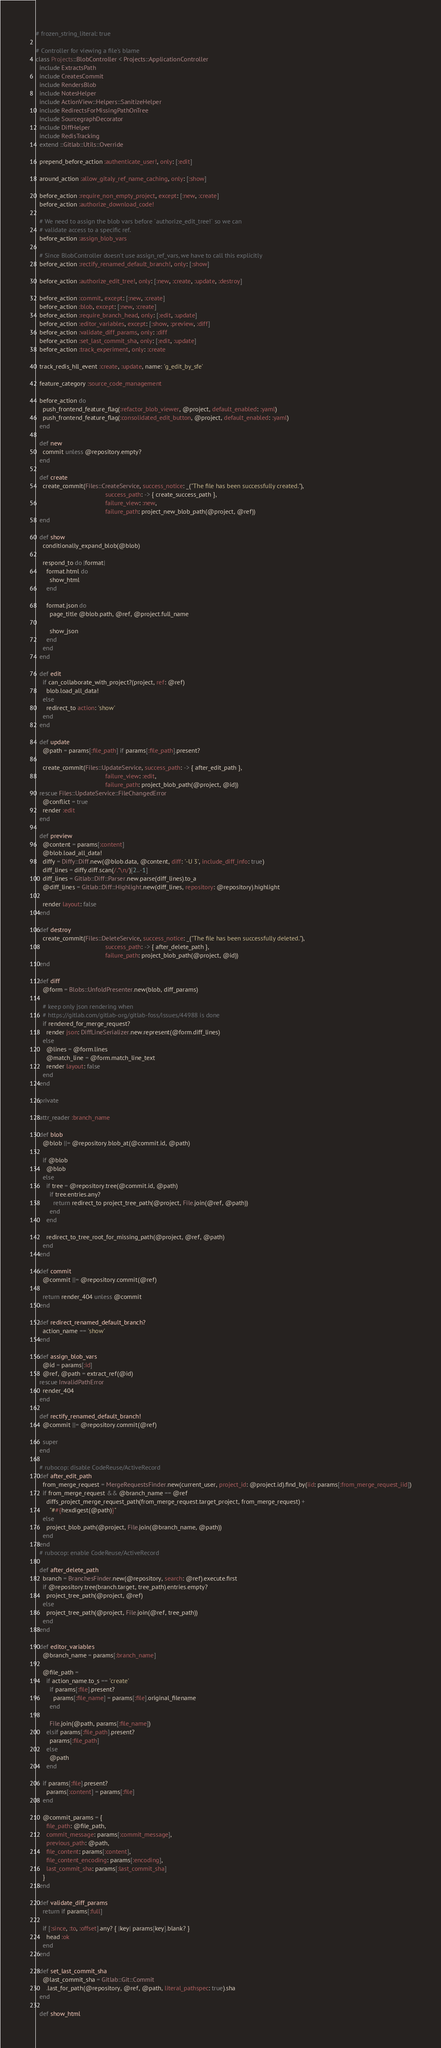<code> <loc_0><loc_0><loc_500><loc_500><_Ruby_># frozen_string_literal: true

# Controller for viewing a file's blame
class Projects::BlobController < Projects::ApplicationController
  include ExtractsPath
  include CreatesCommit
  include RendersBlob
  include NotesHelper
  include ActionView::Helpers::SanitizeHelper
  include RedirectsForMissingPathOnTree
  include SourcegraphDecorator
  include DiffHelper
  include RedisTracking
  extend ::Gitlab::Utils::Override

  prepend_before_action :authenticate_user!, only: [:edit]

  around_action :allow_gitaly_ref_name_caching, only: [:show]

  before_action :require_non_empty_project, except: [:new, :create]
  before_action :authorize_download_code!

  # We need to assign the blob vars before `authorize_edit_tree!` so we can
  # validate access to a specific ref.
  before_action :assign_blob_vars

  # Since BlobController doesn't use assign_ref_vars, we have to call this explicitly
  before_action :rectify_renamed_default_branch!, only: [:show]

  before_action :authorize_edit_tree!, only: [:new, :create, :update, :destroy]

  before_action :commit, except: [:new, :create]
  before_action :blob, except: [:new, :create]
  before_action :require_branch_head, only: [:edit, :update]
  before_action :editor_variables, except: [:show, :preview, :diff]
  before_action :validate_diff_params, only: :diff
  before_action :set_last_commit_sha, only: [:edit, :update]
  before_action :track_experiment, only: :create

  track_redis_hll_event :create, :update, name: 'g_edit_by_sfe'

  feature_category :source_code_management

  before_action do
    push_frontend_feature_flag(:refactor_blob_viewer, @project, default_enabled: :yaml)
    push_frontend_feature_flag(:consolidated_edit_button, @project, default_enabled: :yaml)
  end

  def new
    commit unless @repository.empty?
  end

  def create
    create_commit(Files::CreateService, success_notice: _("The file has been successfully created."),
                                        success_path: -> { create_success_path },
                                        failure_view: :new,
                                        failure_path: project_new_blob_path(@project, @ref))
  end

  def show
    conditionally_expand_blob(@blob)

    respond_to do |format|
      format.html do
        show_html
      end

      format.json do
        page_title @blob.path, @ref, @project.full_name

        show_json
      end
    end
  end

  def edit
    if can_collaborate_with_project?(project, ref: @ref)
      blob.load_all_data!
    else
      redirect_to action: 'show'
    end
  end

  def update
    @path = params[:file_path] if params[:file_path].present?

    create_commit(Files::UpdateService, success_path: -> { after_edit_path },
                                        failure_view: :edit,
                                        failure_path: project_blob_path(@project, @id))
  rescue Files::UpdateService::FileChangedError
    @conflict = true
    render :edit
  end

  def preview
    @content = params[:content]
    @blob.load_all_data!
    diffy = Diffy::Diff.new(@blob.data, @content, diff: '-U 3', include_diff_info: true)
    diff_lines = diffy.diff.scan(/.*\n/)[2..-1]
    diff_lines = Gitlab::Diff::Parser.new.parse(diff_lines).to_a
    @diff_lines = Gitlab::Diff::Highlight.new(diff_lines, repository: @repository).highlight

    render layout: false
  end

  def destroy
    create_commit(Files::DeleteService, success_notice: _("The file has been successfully deleted."),
                                        success_path: -> { after_delete_path },
                                        failure_path: project_blob_path(@project, @id))
  end

  def diff
    @form = Blobs::UnfoldPresenter.new(blob, diff_params)

    # keep only json rendering when
    # https://gitlab.com/gitlab-org/gitlab-foss/issues/44988 is done
    if rendered_for_merge_request?
      render json: DiffLineSerializer.new.represent(@form.diff_lines)
    else
      @lines = @form.lines
      @match_line = @form.match_line_text
      render layout: false
    end
  end

  private

  attr_reader :branch_name

  def blob
    @blob ||= @repository.blob_at(@commit.id, @path)

    if @blob
      @blob
    else
      if tree = @repository.tree(@commit.id, @path)
        if tree.entries.any?
          return redirect_to project_tree_path(@project, File.join(@ref, @path))
        end
      end

      redirect_to_tree_root_for_missing_path(@project, @ref, @path)
    end
  end

  def commit
    @commit ||= @repository.commit(@ref)

    return render_404 unless @commit
  end

  def redirect_renamed_default_branch?
    action_name == 'show'
  end

  def assign_blob_vars
    @id = params[:id]
    @ref, @path = extract_ref(@id)
  rescue InvalidPathError
    render_404
  end

  def rectify_renamed_default_branch!
    @commit ||= @repository.commit(@ref)

    super
  end

  # rubocop: disable CodeReuse/ActiveRecord
  def after_edit_path
    from_merge_request = MergeRequestsFinder.new(current_user, project_id: @project.id).find_by(iid: params[:from_merge_request_iid])
    if from_merge_request && @branch_name == @ref
      diffs_project_merge_request_path(from_merge_request.target_project, from_merge_request) +
        "##{hexdigest(@path)}"
    else
      project_blob_path(@project, File.join(@branch_name, @path))
    end
  end
  # rubocop: enable CodeReuse/ActiveRecord

  def after_delete_path
    branch = BranchesFinder.new(@repository, search: @ref).execute.first
    if @repository.tree(branch.target, tree_path).entries.empty?
      project_tree_path(@project, @ref)
    else
      project_tree_path(@project, File.join(@ref, tree_path))
    end
  end

  def editor_variables
    @branch_name = params[:branch_name]

    @file_path =
      if action_name.to_s == 'create'
        if params[:file].present?
          params[:file_name] = params[:file].original_filename
        end

        File.join(@path, params[:file_name])
      elsif params[:file_path].present?
        params[:file_path]
      else
        @path
      end

    if params[:file].present?
      params[:content] = params[:file]
    end

    @commit_params = {
      file_path: @file_path,
      commit_message: params[:commit_message],
      previous_path: @path,
      file_content: params[:content],
      file_content_encoding: params[:encoding],
      last_commit_sha: params[:last_commit_sha]
    }
  end

  def validate_diff_params
    return if params[:full]

    if [:since, :to, :offset].any? { |key| params[key].blank? }
      head :ok
    end
  end

  def set_last_commit_sha
    @last_commit_sha = Gitlab::Git::Commit
      .last_for_path(@repository, @ref, @path, literal_pathspec: true).sha
  end

  def show_html</code> 